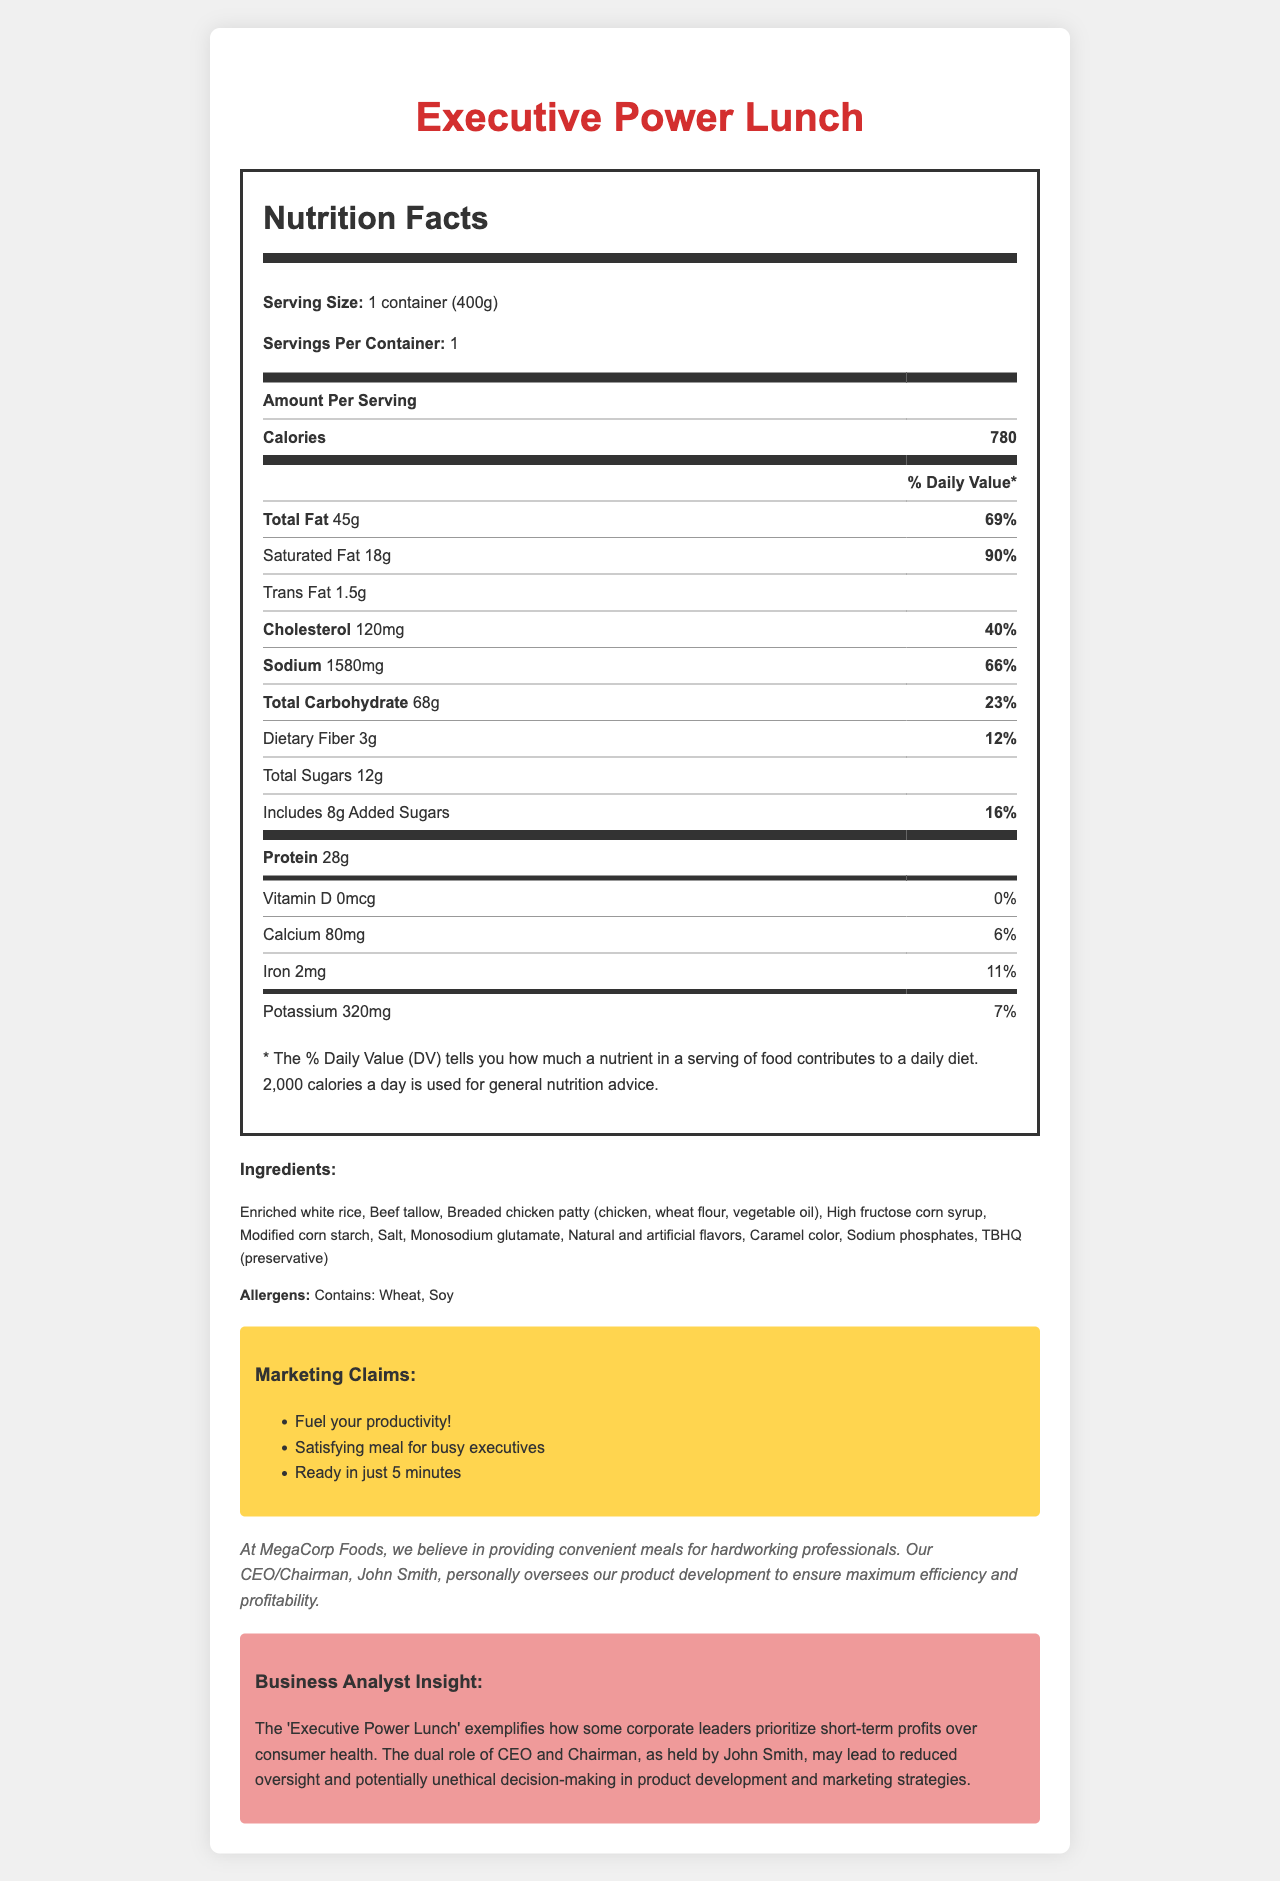what is the serving size of the Executive Power Lunch? The serving size is stated as "1 container (400g)" in the Nutrition Facts section of the document.
Answer: 1 container (400g) how many calories are in one serving of the Executive Power Lunch? The document states "Calories" as 780 under the Amount Per Serving section.
Answer: 780 how much saturated fat does the meal contain? The document mentions "Saturated Fat 18g" in the Total Fat section.
Answer: 18g what is the sodium content of the meal? The sodium content is listed as 1580mg under the Amount Per Serving section.
Answer: 1580mg how many grams of protein are in this meal? The document provides the value of "Protein 28g" under the Amount Per Serving section.
Answer: 28g which of the following are allergens present in the Executive Power Lunch? A. Wheat B. Soy C. Milk D. Eggs The document states that the allergens are "Contains: Wheat, Soy".
Answer: A, B what are some of the marketing claims for this meal? A. Organic ingredients B. Fuel your productivity C. Ready in just 5 minutes D. Gluten-free The document lists marketing claims such as "Fuel your productivity!" and "Ready in just 5 minutes".
Answer: B, C does the document mention the presence of high fructose corn syrup in the ingredients? The ingredients list includes "High fructose corn syrup".
Answer: Yes is this meal a good source of dietary fiber? The document states the dietary fiber content is only 3g, which is relatively low.
Answer: No summarize the main nutritional concerns of the Executive Power Lunch. The nutritionist's comment and the values provided indicate high saturated fat (18g) and sodium (1580mg), along with low dietary fiber (3g) and minimal vitamins and minerals, leading to potential long-term health risks.
Answer: The Executive Power Lunch is high in saturated fat and sodium, which may contribute to heart disease and high blood pressure. Additionally, it lacks significant amounts of essential nutrients like fiber, vitamins, and minerals. Regular consumption of such meals may lead to long-term health issues. who personally oversees product development at MegaCorp Foods? The corporate responsibility statement mentions that the CEO/Chairman, John Smith, personally oversees product development.
Answer: John Smith can you determine the exact percentage of Vitamin C in the meal? The document does not provide enough information or the percentage of Daily Value for Vitamin C.
Answer: Not enough information how does the dual role of CEO and Chairman impact decisions at MegaCorp Foods according to the business analyst? The business analyst insight mentions that holding both roles may prioritize short-term profits over consumer health, leading to less oversight and potentially unethical decisions.
Answer: It may lead to reduced oversight and potentially unethical decision-making in product development and marketing strategies. 